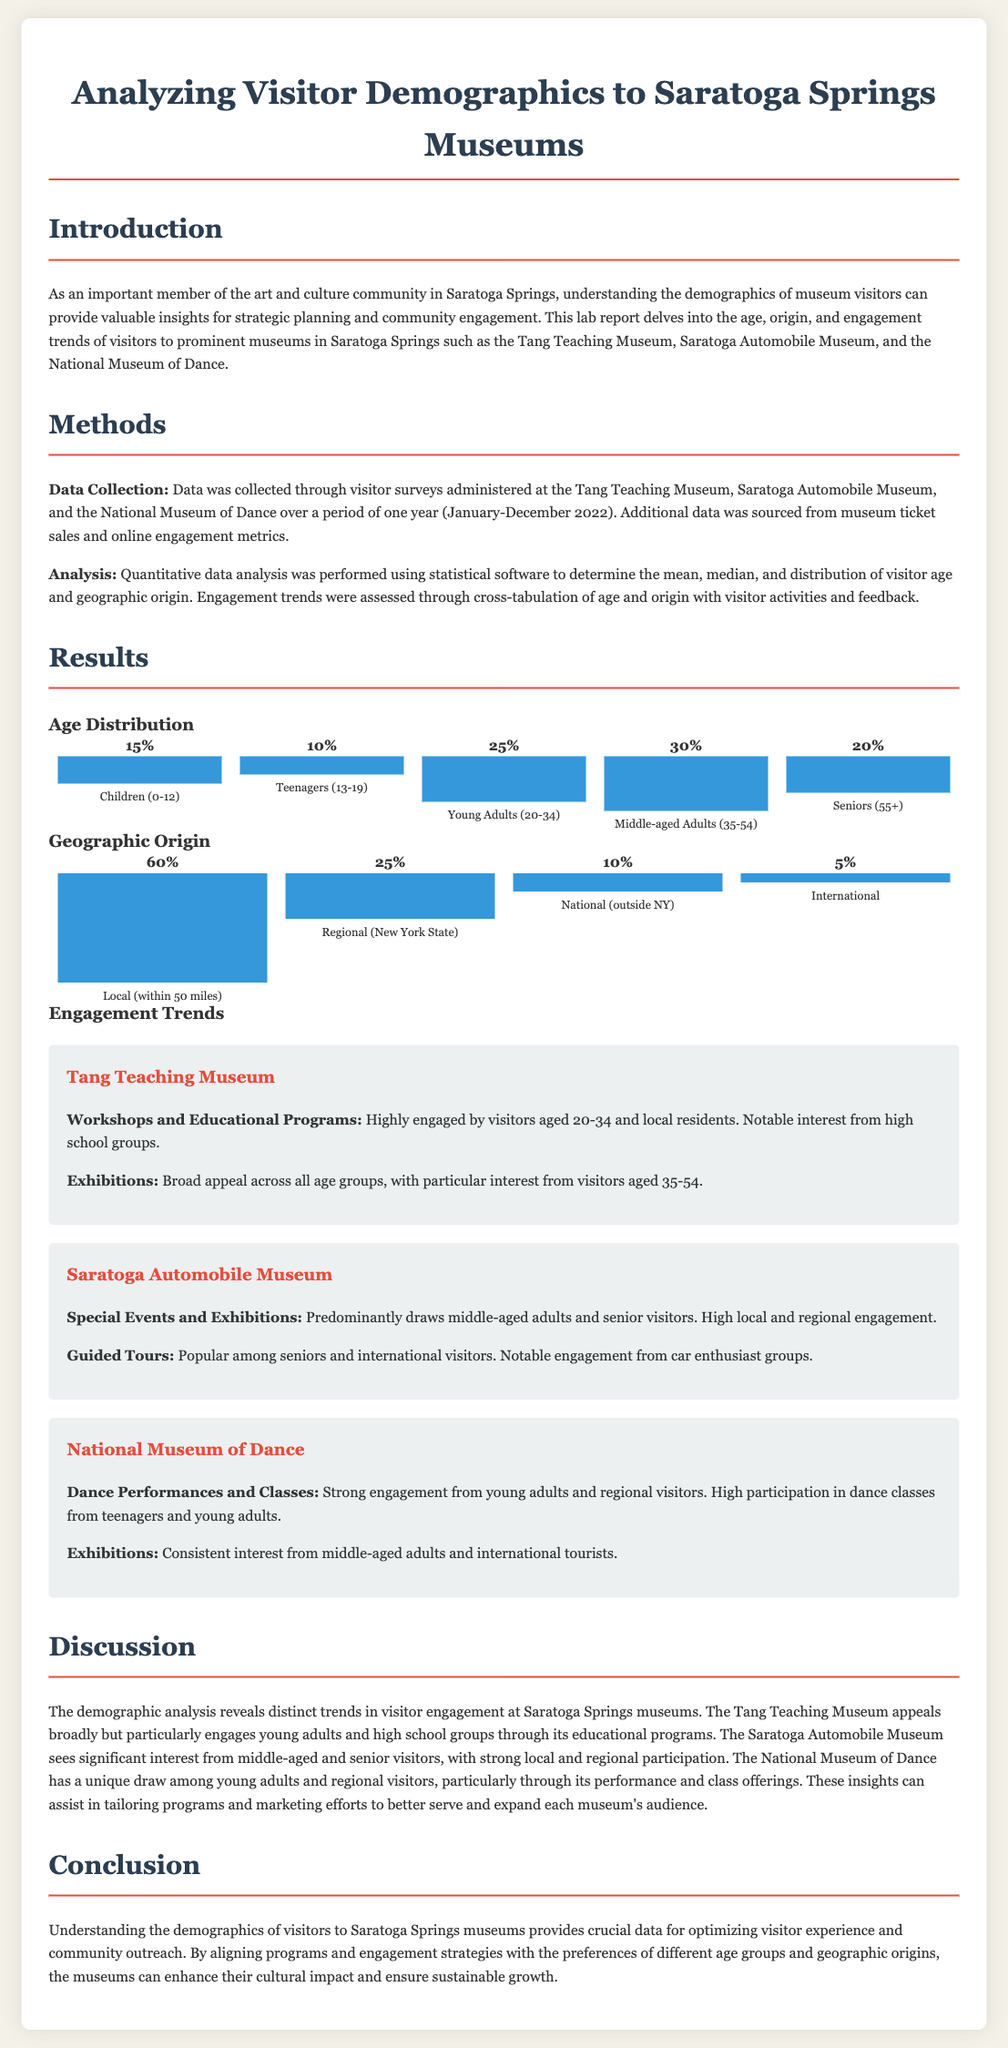What is the percentage of children visitors (0-12)? The document states that children (0-12) constitute 15% of the visitors.
Answer: 15% What age group has the highest percentage of visitors? The highest percentage of visitors is found in the middle-aged adults (35-54) category with 30%.
Answer: 30% How many percentage points of visitors are from international origins? According to the document, international visitors represent 5% of the total.
Answer: 5% Which museum has strong engagement from young adults? The document mentions that the National Museum of Dance has strong engagement from young adults.
Answer: National Museum of Dance What visitor age group is particularly engaged by the Tang Teaching Museum's workshops? The Tang Teaching Museum's workshops are highly engaged by visitors aged 20-34.
Answer: 20-34 What percentage of visitors are local (within 50 miles)? The document indicates that 60% of the visitors are local, within 50 miles.
Answer: 60% Which age group shows notable interest in the exhibitions at the Tang Teaching Museum? Visitors aged 35-54 show particular interest in the exhibitions.
Answer: 35-54 How many museums are analyzed in the report? The analysis covers three museums in Saratoga Springs.
Answer: Three What is the primary method mentioned for data collection? Visitor surveys administered at the museums is the primary method for data collection.
Answer: Visitor surveys 